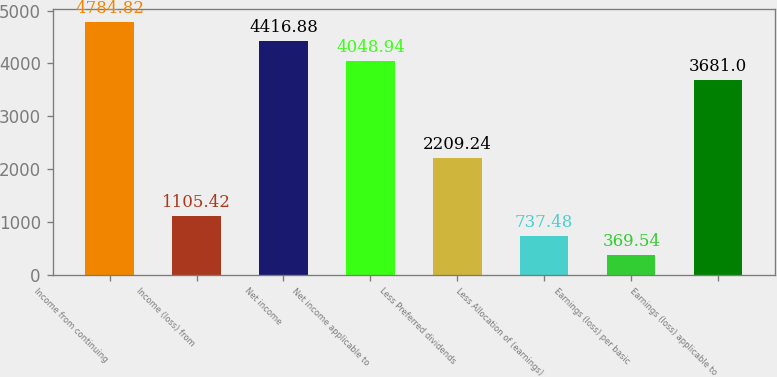Convert chart. <chart><loc_0><loc_0><loc_500><loc_500><bar_chart><fcel>Income from continuing<fcel>Income (loss) from<fcel>Net income<fcel>Net income applicable to<fcel>Less Preferred dividends<fcel>Less Allocation of (earnings)<fcel>Earnings (loss) per basic<fcel>Earnings (loss) applicable to<nl><fcel>4784.82<fcel>1105.42<fcel>4416.88<fcel>4048.94<fcel>2209.24<fcel>737.48<fcel>369.54<fcel>3681<nl></chart> 